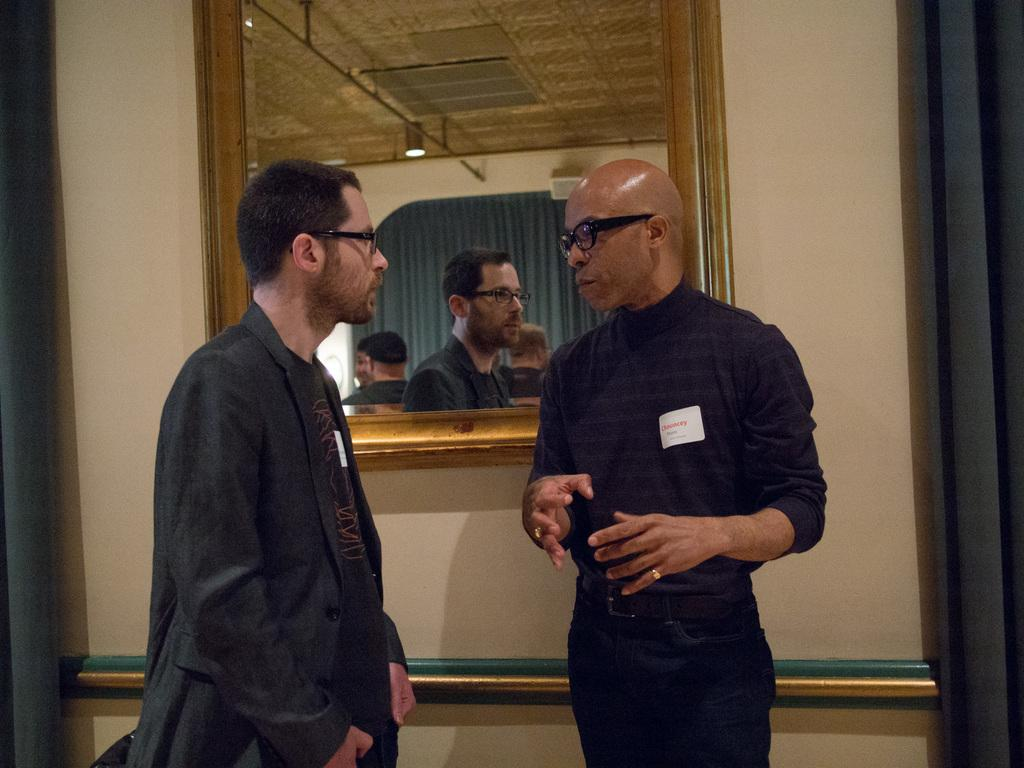What is the ethnicity of the man in the image? The man in the image is African. What is the African man wearing? The African man is wearing a black shirt and pants. What is the African man doing in the image? The African man is talking to another person. What is the other person wearing? The other person is wearing a black coat. What can be seen in the background of the image? There is a mirror and a brown-colored wall in the background of the image. What type of beef is being discussed in the conversation between the African man and the other person? There is no mention of beef or any discussion about it in the image. 